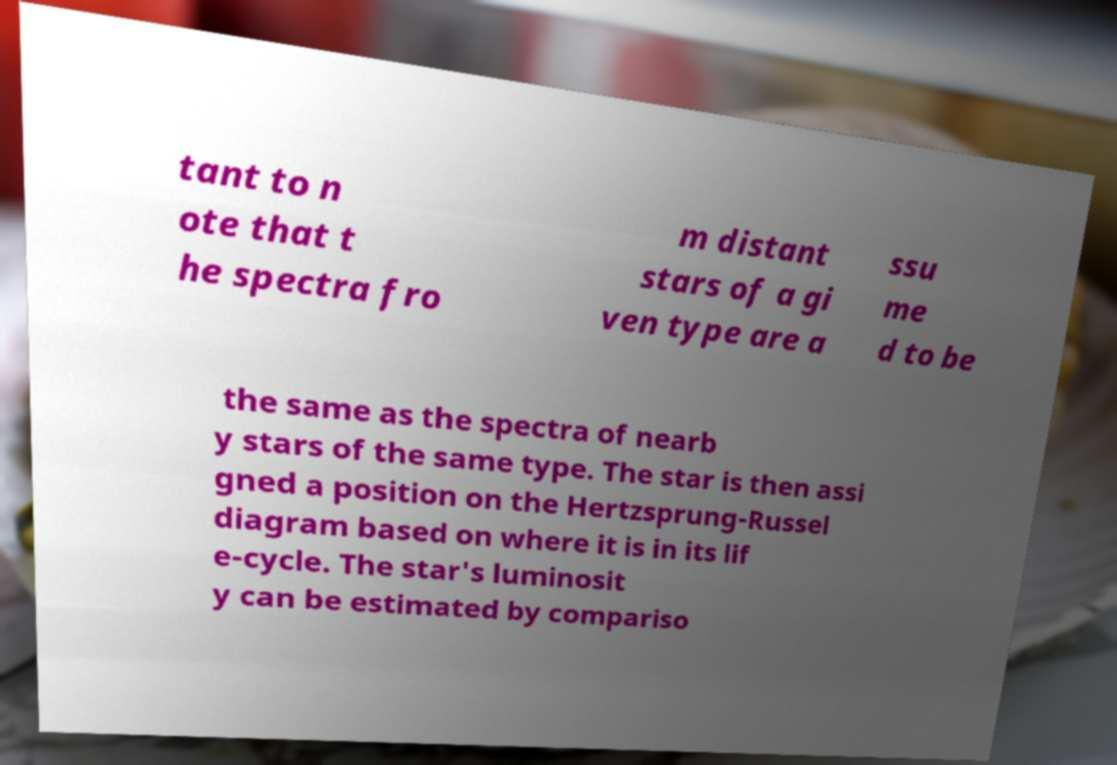Please identify and transcribe the text found in this image. tant to n ote that t he spectra fro m distant stars of a gi ven type are a ssu me d to be the same as the spectra of nearb y stars of the same type. The star is then assi gned a position on the Hertzsprung-Russel diagram based on where it is in its lif e-cycle. The star's luminosit y can be estimated by compariso 